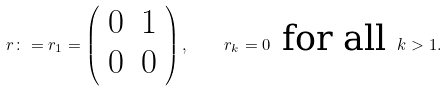Convert formula to latex. <formula><loc_0><loc_0><loc_500><loc_500>r \colon = r _ { 1 } = \left ( \begin{array} { c c } 0 & 1 \\ 0 & 0 \end{array} \right ) , \quad r _ { k } = 0 \text { for all } k > 1 .</formula> 